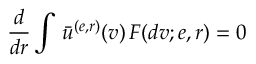Convert formula to latex. <formula><loc_0><loc_0><loc_500><loc_500>\frac { d } { d r } \int \, \bar { u } ^ { ( e , r ) } ( v ) \, F ( d v ; e , r ) = 0</formula> 